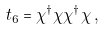Convert formula to latex. <formula><loc_0><loc_0><loc_500><loc_500>t _ { 6 } = \chi ^ { \dag } \chi \chi ^ { \dag } \chi \, ,</formula> 